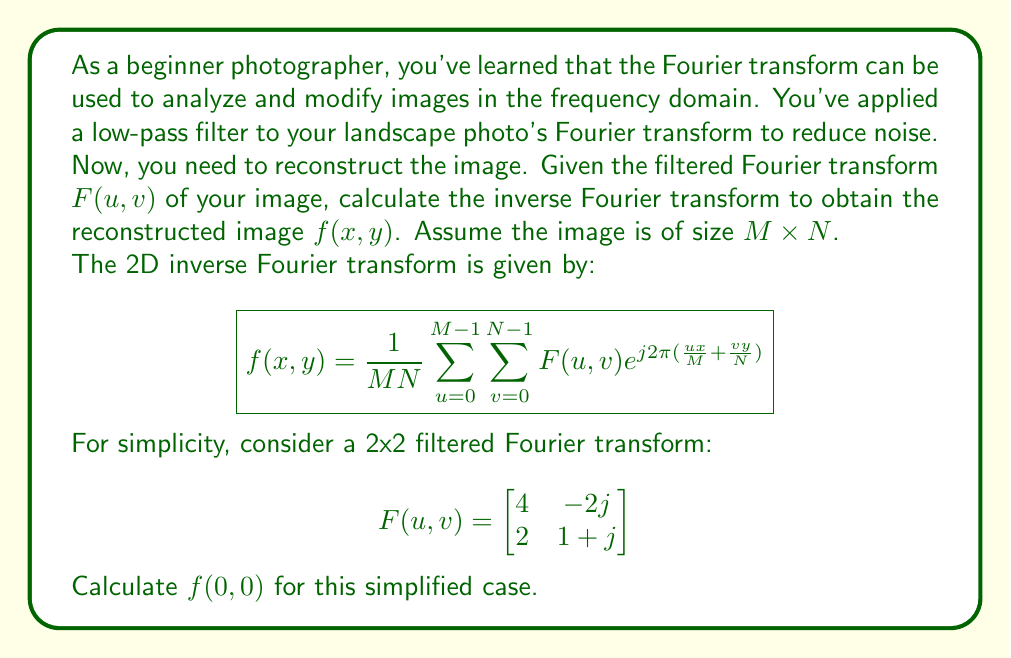Provide a solution to this math problem. To calculate $f(0,0)$, we'll use the inverse Fourier transform formula with $x=0$ and $y=0$:

1) For a 2x2 image, $M=N=2$, so the formula simplifies to:

   $$f(0,0) = \frac{1}{4} \sum_{u=0}^{1} \sum_{v=0}^{1} F(u,v) e^{j2\pi(\frac{u \cdot 0}{2} + \frac{v \cdot 0}{2})}$$

2) Note that $e^{j2\pi(\frac{u \cdot 0}{2} + \frac{v \cdot 0}{2})} = e^0 = 1$ for all $u$ and $v$.

3) So, we simply need to sum all elements of $F(u,v)$ and divide by 4:

   $$f(0,0) = \frac{1}{4} [F(0,0) + F(0,1) + F(1,0) + F(1,1)]$$

4) Substituting the values:

   $$f(0,0) = \frac{1}{4} [4 + (-2j) + 2 + (1+j)]$$

5) Simplifying:

   $$f(0,0) = \frac{1}{4} [7 - j]$$

6) Separating real and imaginary parts:

   $$f(0,0) = \frac{7}{4} - \frac{j}{4}$$

This is the value of the reconstructed image at point (0,0).
Answer: $f(0,0) = \frac{7}{4} - \frac{j}{4}$ 